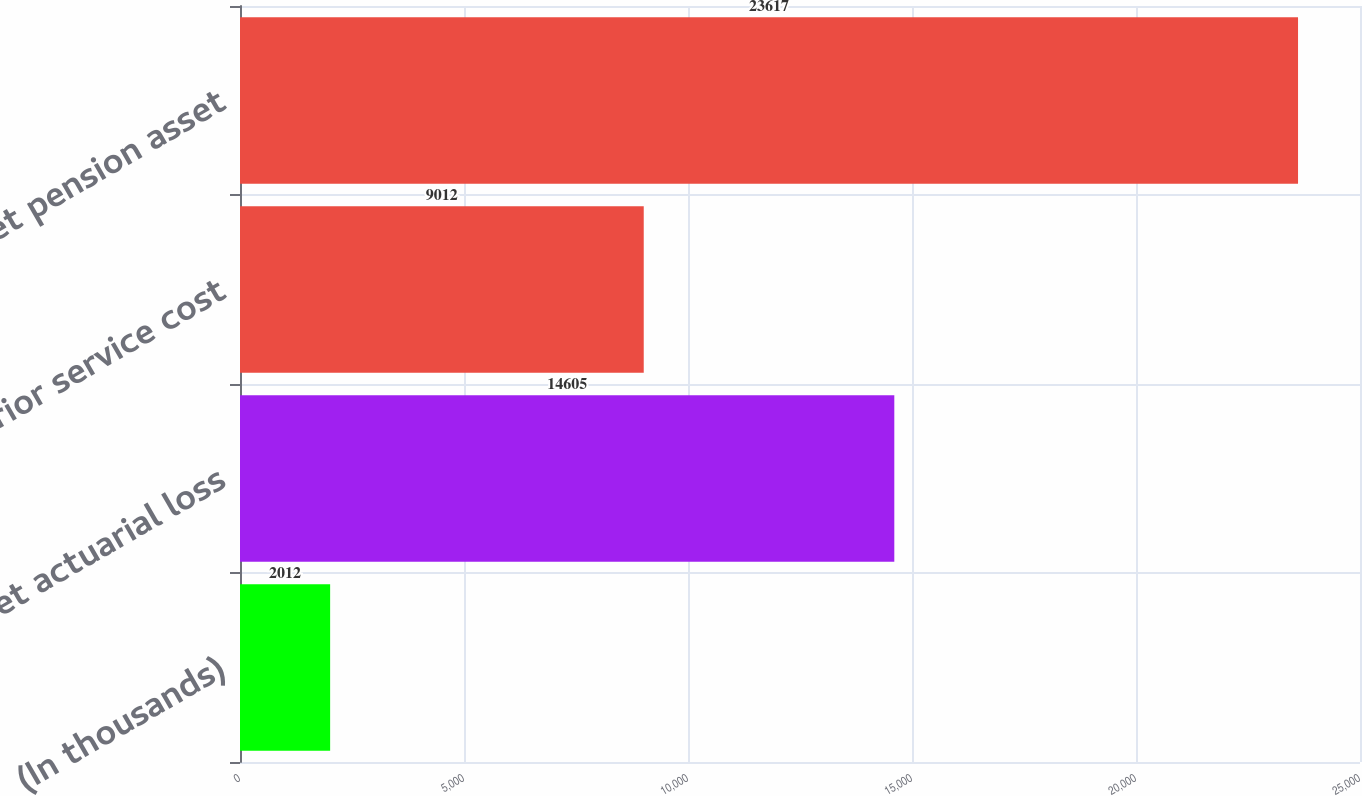<chart> <loc_0><loc_0><loc_500><loc_500><bar_chart><fcel>(In thousands)<fcel>Net actuarial loss<fcel>Prior service cost<fcel>Net pension asset<nl><fcel>2012<fcel>14605<fcel>9012<fcel>23617<nl></chart> 